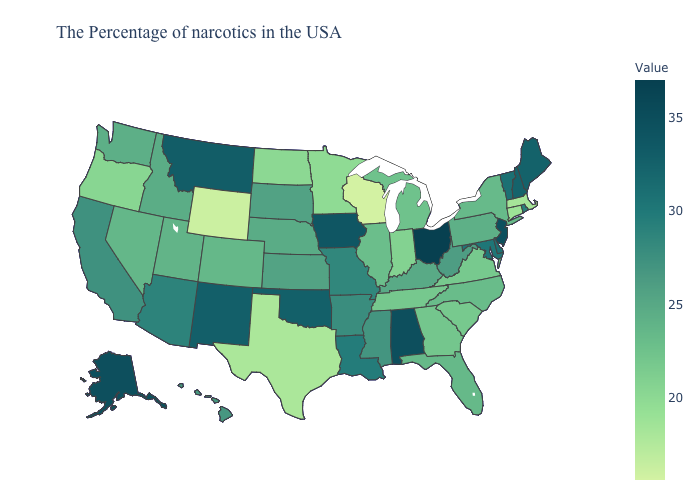Does Washington have the highest value in the West?
Be succinct. No. Does Pennsylvania have the lowest value in the Northeast?
Keep it brief. No. Which states have the highest value in the USA?
Give a very brief answer. Ohio. Which states have the lowest value in the MidWest?
Keep it brief. Wisconsin. Is the legend a continuous bar?
Be succinct. Yes. Which states hav the highest value in the West?
Quick response, please. Alaska. Does Maine have the highest value in the USA?
Give a very brief answer. No. 